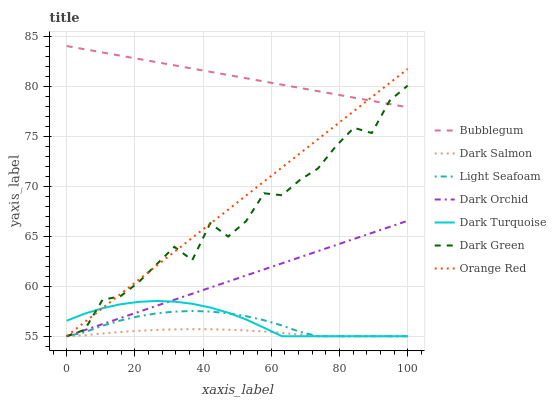Does Dark Orchid have the minimum area under the curve?
Answer yes or no. No. Does Dark Orchid have the maximum area under the curve?
Answer yes or no. No. Is Dark Salmon the smoothest?
Answer yes or no. No. Is Dark Salmon the roughest?
Answer yes or no. No. Does Bubblegum have the lowest value?
Answer yes or no. No. Does Dark Orchid have the highest value?
Answer yes or no. No. Is Dark Turquoise less than Bubblegum?
Answer yes or no. Yes. Is Bubblegum greater than Dark Turquoise?
Answer yes or no. Yes. Does Dark Turquoise intersect Bubblegum?
Answer yes or no. No. 